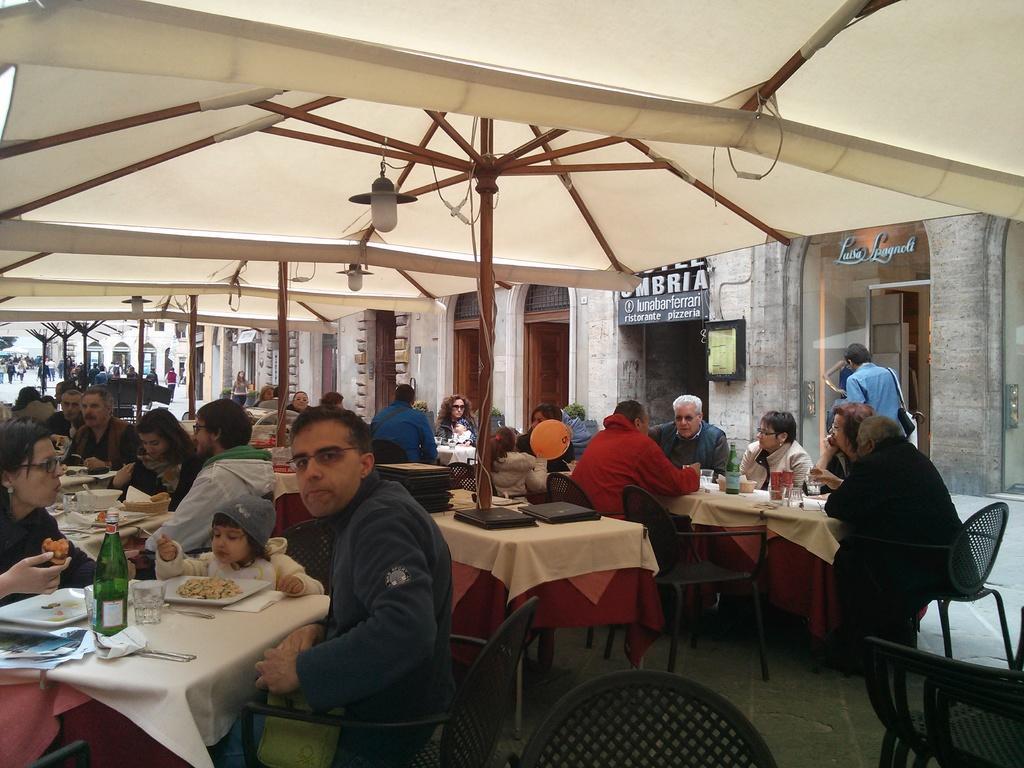Can you describe this image briefly? This picture shows a restaurant where group of people seated and having food in the plates and we see glasses and water bottles on the table 